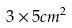Convert formula to latex. <formula><loc_0><loc_0><loc_500><loc_500>3 \times 5 c m ^ { 2 }</formula> 